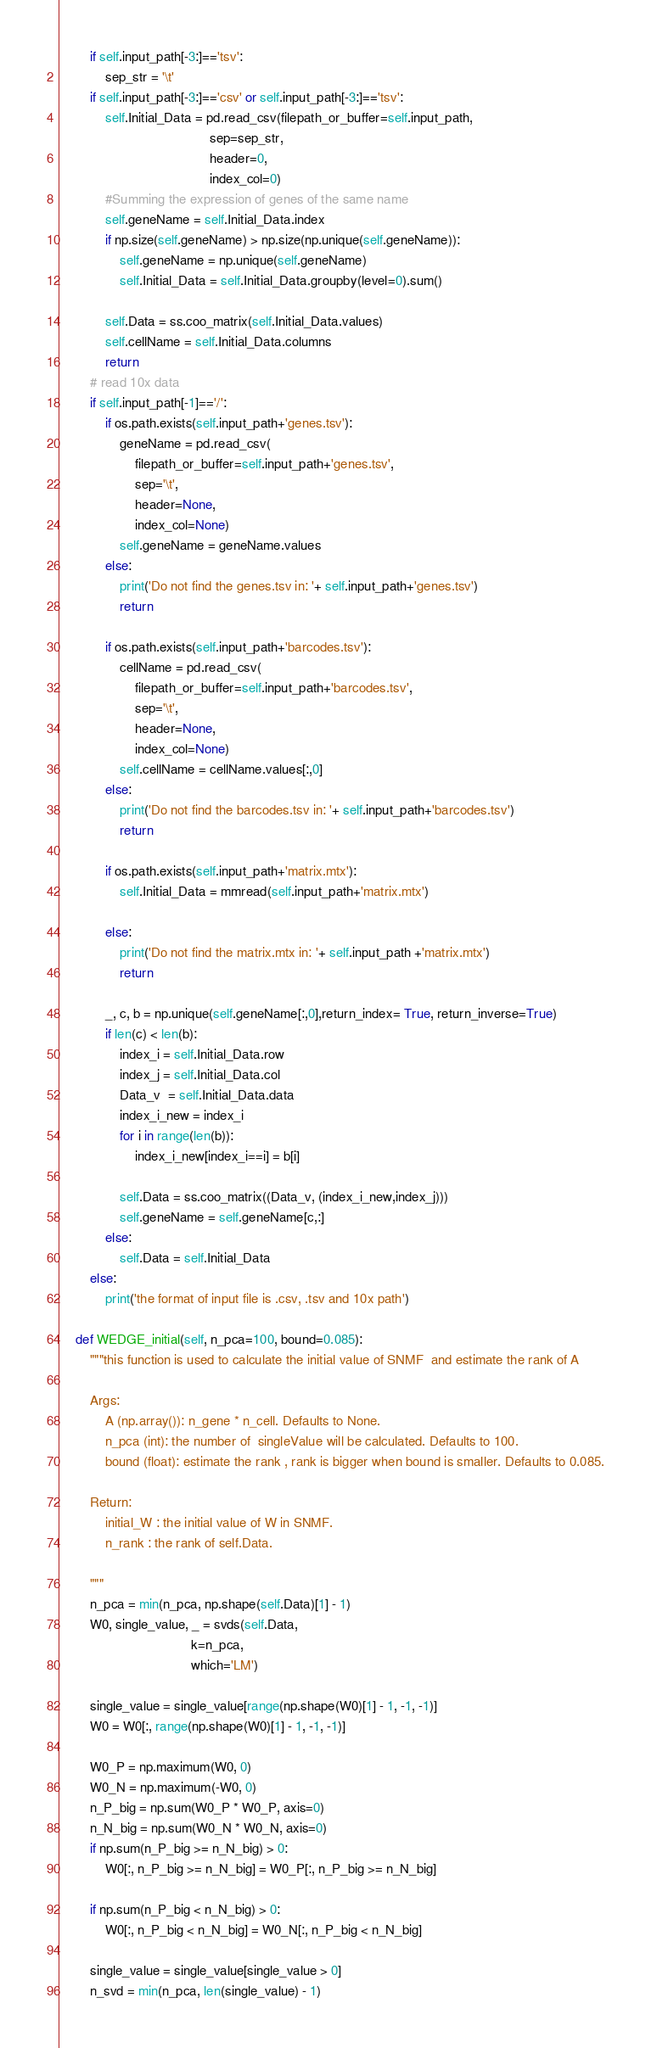Convert code to text. <code><loc_0><loc_0><loc_500><loc_500><_Python_>        if self.input_path[-3:]=='tsv':
            sep_str = '\t'
        if self.input_path[-3:]=='csv' or self.input_path[-3:]=='tsv':
            self.Initial_Data = pd.read_csv(filepath_or_buffer=self.input_path,
                                        sep=sep_str,
                                        header=0,
                                        index_col=0)
            #Summing the expression of genes of the same name
            self.geneName = self.Initial_Data.index
            if np.size(self.geneName) > np.size(np.unique(self.geneName)):
                self.geneName = np.unique(self.geneName)
                self.Initial_Data = self.Initial_Data.groupby(level=0).sum()

            self.Data = ss.coo_matrix(self.Initial_Data.values)
            self.cellName = self.Initial_Data.columns
            return
        # read 10x data
        if self.input_path[-1]=='/':
            if os.path.exists(self.input_path+'genes.tsv'):
                geneName = pd.read_csv(
                    filepath_or_buffer=self.input_path+'genes.tsv',
                    sep='\t',
                    header=None,
                    index_col=None)
                self.geneName = geneName.values
            else:
                print('Do not find the genes.tsv in: '+ self.input_path+'genes.tsv')
                return 

            if os.path.exists(self.input_path+'barcodes.tsv'):
                cellName = pd.read_csv(
                    filepath_or_buffer=self.input_path+'barcodes.tsv',
                    sep='\t',
                    header=None,
                    index_col=None)
                self.cellName = cellName.values[:,0]
            else:
                print('Do not find the barcodes.tsv in: '+ self.input_path+'barcodes.tsv')
                return

            if os.path.exists(self.input_path+'matrix.mtx'):
                self.Initial_Data = mmread(self.input_path+'matrix.mtx')

            else:
                print('Do not find the matrix.mtx in: '+ self.input_path +'matrix.mtx')
                return 
            
            _, c, b = np.unique(self.geneName[:,0],return_index= True, return_inverse=True)
            if len(c) < len(b):
                index_i = self.Initial_Data.row
                index_j = self.Initial_Data.col
                Data_v  = self.Initial_Data.data
                index_i_new = index_i
                for i in range(len(b)):
                    index_i_new[index_i==i] = b[i] 

                self.Data = ss.coo_matrix((Data_v, (index_i_new,index_j)))
                self.geneName = self.geneName[c,:]
            else:
                self.Data = self.Initial_Data
        else:
            print('the format of input file is .csv, .tsv and 10x path')

    def WEDGE_initial(self, n_pca=100, bound=0.085):
        """this function is used to calculate the initial value of SNMF  and estimate the rank of A

        Args:
            A (np.array()): n_gene * n_cell. Defaults to None.
            n_pca (int): the number of  singleValue will be calculated. Defaults to 100.
            bound (float): estimate the rank , rank is bigger when bound is smaller. Defaults to 0.085.

        Return:
            initial_W : the initial value of W in SNMF.
            n_rank : the rank of self.Data.

        """
        n_pca = min(n_pca, np.shape(self.Data)[1] - 1)
        W0, single_value, _ = svds(self.Data,
                                   k=n_pca,
                                   which='LM')

        single_value = single_value[range(np.shape(W0)[1] - 1, -1, -1)]
        W0 = W0[:, range(np.shape(W0)[1] - 1, -1, -1)]

        W0_P = np.maximum(W0, 0)
        W0_N = np.maximum(-W0, 0)
        n_P_big = np.sum(W0_P * W0_P, axis=0)
        n_N_big = np.sum(W0_N * W0_N, axis=0)
        if np.sum(n_P_big >= n_N_big) > 0:
            W0[:, n_P_big >= n_N_big] = W0_P[:, n_P_big >= n_N_big]

        if np.sum(n_P_big < n_N_big) > 0:
            W0[:, n_P_big < n_N_big] = W0_N[:, n_P_big < n_N_big]

        single_value = single_value[single_value > 0]
        n_svd = min(n_pca, len(single_value) - 1)</code> 